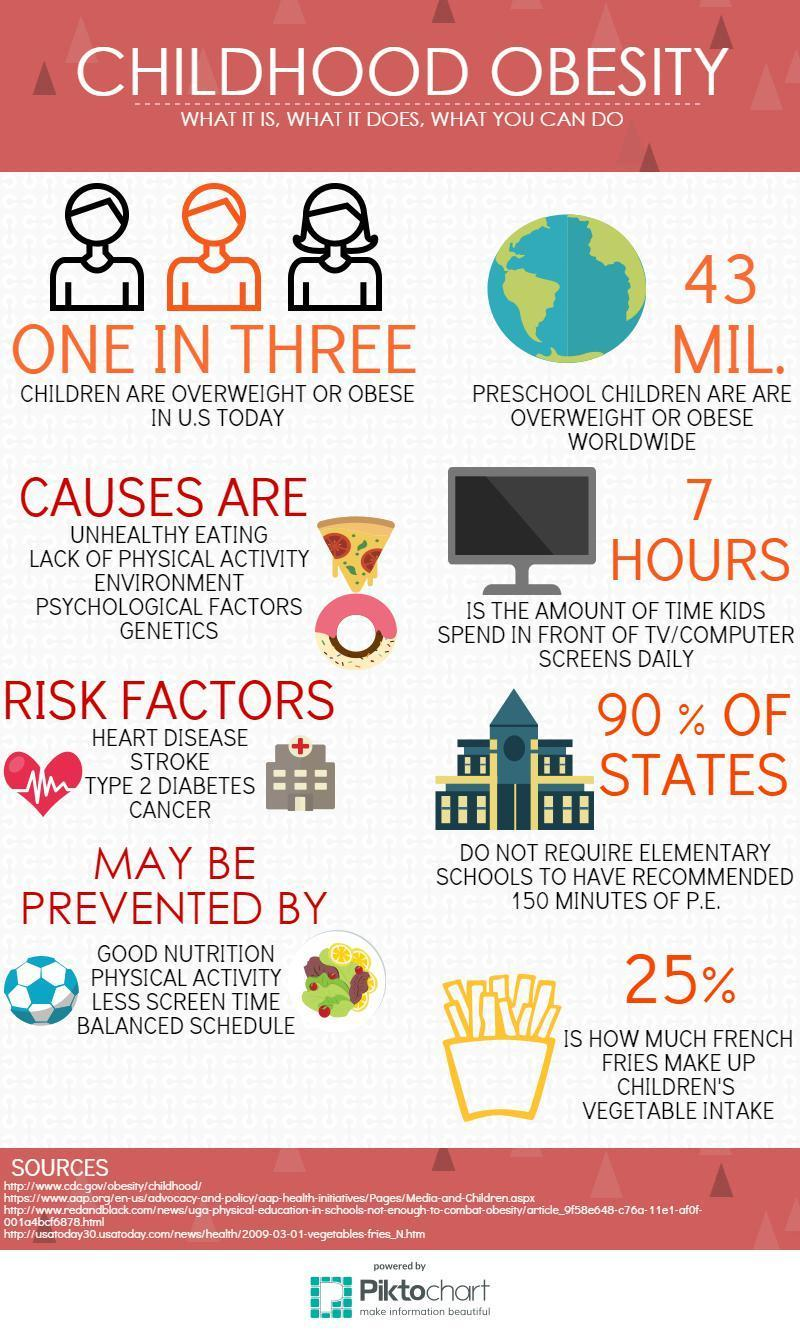Out of 3, how many children are not overweight?
Answer the question with a short phrase. 2 What is the fifth reason for childhood obesity in this infographic? Genetics What is the fourth reason for childhood obesity in this infographic? Psychological factors What is the number of reasons for childhood obesity? 5 In how many ways childhood obesity gets prevented? 4 What is the second risk factor in childhood obesity? Stroke How many risk factors for childhood obesity? 4 